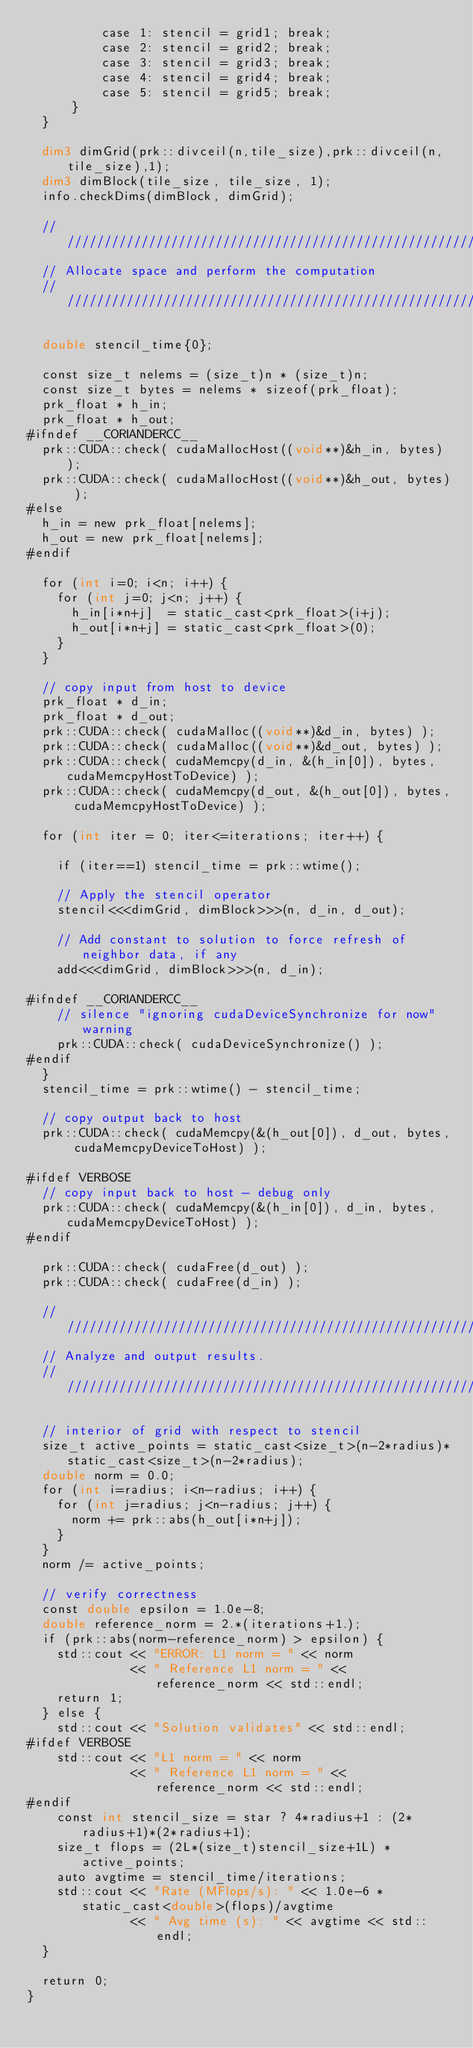Convert code to text. <code><loc_0><loc_0><loc_500><loc_500><_Cuda_>          case 1: stencil = grid1; break;
          case 2: stencil = grid2; break;
          case 3: stencil = grid3; break;
          case 4: stencil = grid4; break;
          case 5: stencil = grid5; break;
      }
  }

  dim3 dimGrid(prk::divceil(n,tile_size),prk::divceil(n,tile_size),1);
  dim3 dimBlock(tile_size, tile_size, 1);
  info.checkDims(dimBlock, dimGrid);

  //////////////////////////////////////////////////////////////////////
  // Allocate space and perform the computation
  //////////////////////////////////////////////////////////////////////

  double stencil_time{0};

  const size_t nelems = (size_t)n * (size_t)n;
  const size_t bytes = nelems * sizeof(prk_float);
  prk_float * h_in;
  prk_float * h_out;
#ifndef __CORIANDERCC__
  prk::CUDA::check( cudaMallocHost((void**)&h_in, bytes) );
  prk::CUDA::check( cudaMallocHost((void**)&h_out, bytes) );
#else
  h_in = new prk_float[nelems];
  h_out = new prk_float[nelems];
#endif

  for (int i=0; i<n; i++) {
    for (int j=0; j<n; j++) {
      h_in[i*n+j]  = static_cast<prk_float>(i+j);
      h_out[i*n+j] = static_cast<prk_float>(0);
    }
  }

  // copy input from host to device
  prk_float * d_in;
  prk_float * d_out;
  prk::CUDA::check( cudaMalloc((void**)&d_in, bytes) );
  prk::CUDA::check( cudaMalloc((void**)&d_out, bytes) );
  prk::CUDA::check( cudaMemcpy(d_in, &(h_in[0]), bytes, cudaMemcpyHostToDevice) );
  prk::CUDA::check( cudaMemcpy(d_out, &(h_out[0]), bytes, cudaMemcpyHostToDevice) );

  for (int iter = 0; iter<=iterations; iter++) {

    if (iter==1) stencil_time = prk::wtime();

    // Apply the stencil operator
    stencil<<<dimGrid, dimBlock>>>(n, d_in, d_out);

    // Add constant to solution to force refresh of neighbor data, if any
    add<<<dimGrid, dimBlock>>>(n, d_in);

#ifndef __CORIANDERCC__
    // silence "ignoring cudaDeviceSynchronize for now" warning
    prk::CUDA::check( cudaDeviceSynchronize() );
#endif
  }
  stencil_time = prk::wtime() - stencil_time;

  // copy output back to host
  prk::CUDA::check( cudaMemcpy(&(h_out[0]), d_out, bytes, cudaMemcpyDeviceToHost) );

#ifdef VERBOSE
  // copy input back to host - debug only
  prk::CUDA::check( cudaMemcpy(&(h_in[0]), d_in, bytes, cudaMemcpyDeviceToHost) );
#endif

  prk::CUDA::check( cudaFree(d_out) );
  prk::CUDA::check( cudaFree(d_in) );

  //////////////////////////////////////////////////////////////////////
  // Analyze and output results.
  //////////////////////////////////////////////////////////////////////

  // interior of grid with respect to stencil
  size_t active_points = static_cast<size_t>(n-2*radius)*static_cast<size_t>(n-2*radius);
  double norm = 0.0;
  for (int i=radius; i<n-radius; i++) {
    for (int j=radius; j<n-radius; j++) {
      norm += prk::abs(h_out[i*n+j]);
    }
  }
  norm /= active_points;

  // verify correctness
  const double epsilon = 1.0e-8;
  double reference_norm = 2.*(iterations+1.);
  if (prk::abs(norm-reference_norm) > epsilon) {
    std::cout << "ERROR: L1 norm = " << norm
              << " Reference L1 norm = " << reference_norm << std::endl;
    return 1;
  } else {
    std::cout << "Solution validates" << std::endl;
#ifdef VERBOSE
    std::cout << "L1 norm = " << norm
              << " Reference L1 norm = " << reference_norm << std::endl;
#endif
    const int stencil_size = star ? 4*radius+1 : (2*radius+1)*(2*radius+1);
    size_t flops = (2L*(size_t)stencil_size+1L) * active_points;
    auto avgtime = stencil_time/iterations;
    std::cout << "Rate (MFlops/s): " << 1.0e-6 * static_cast<double>(flops)/avgtime
              << " Avg time (s): " << avgtime << std::endl;
  }

  return 0;
}
</code> 